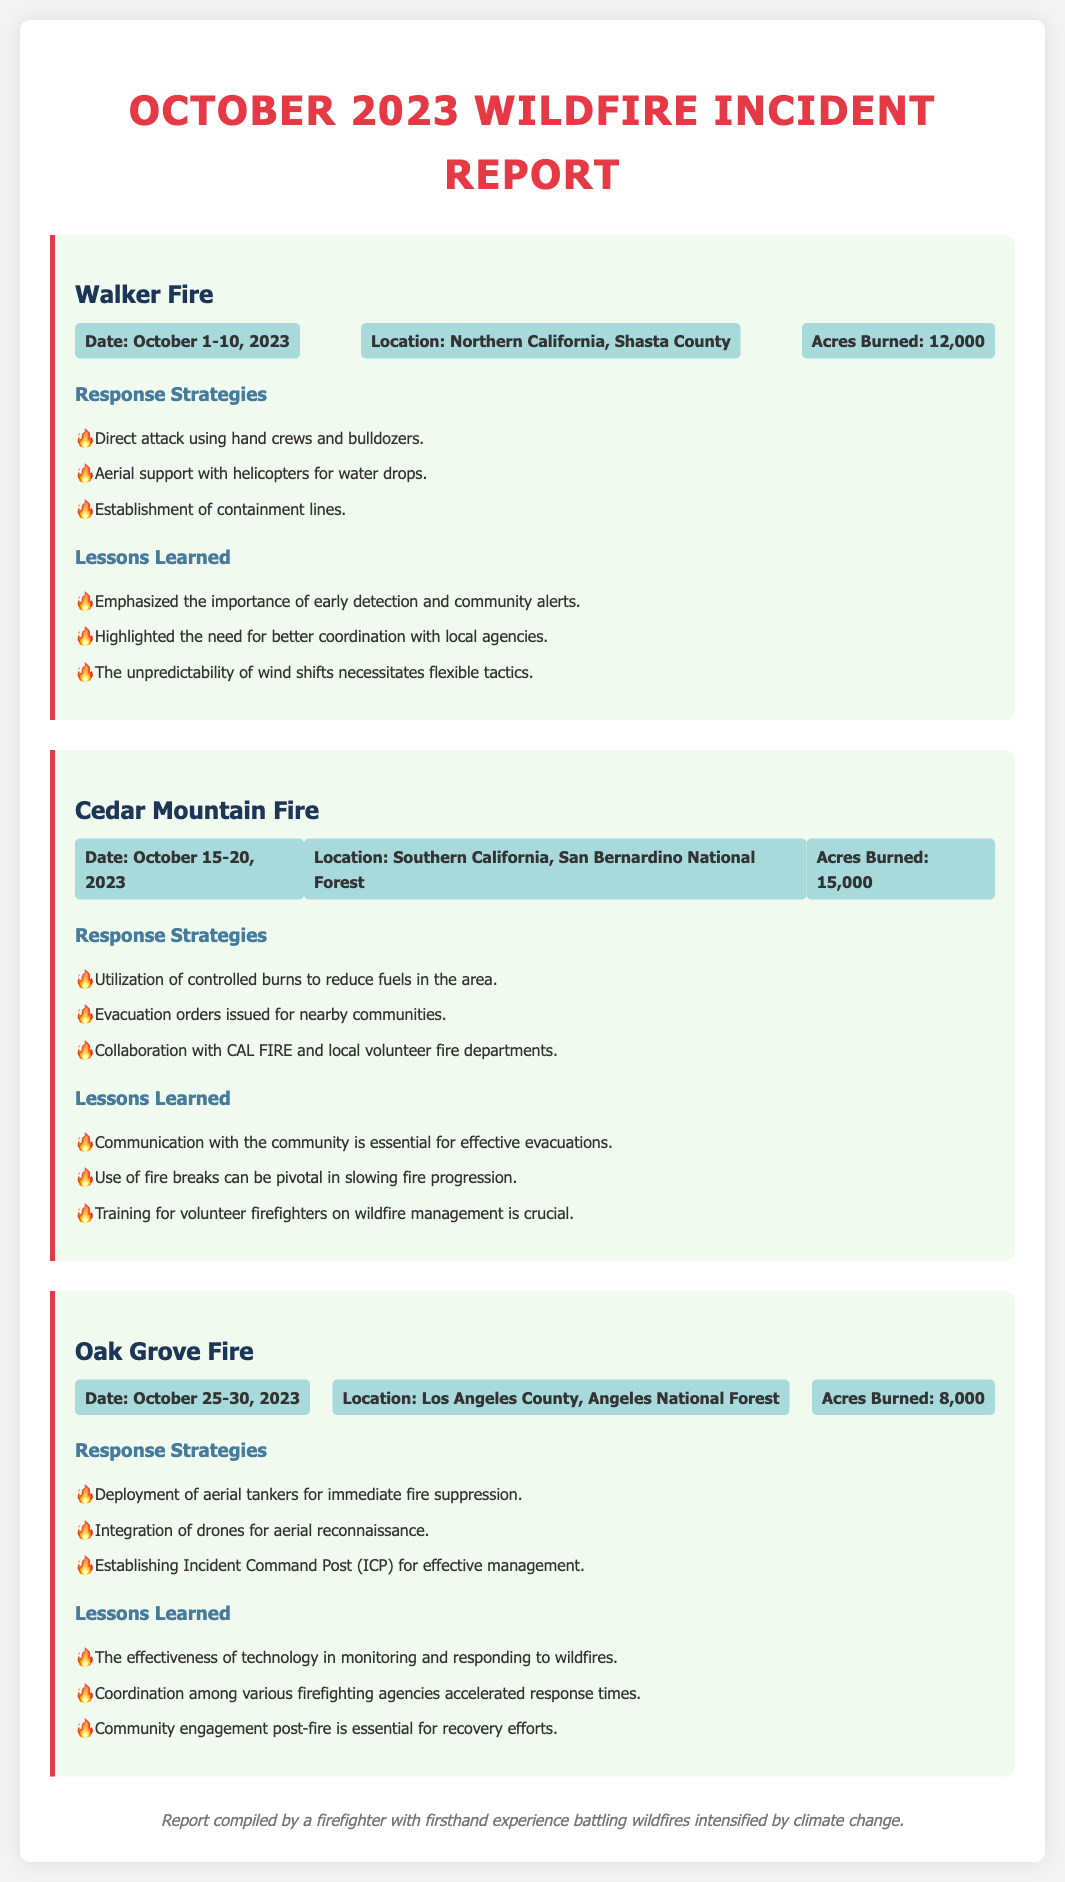What is the name of the first fire reported? The first fire reported in the document is the Walker Fire.
Answer: Walker Fire How many acres were burned in the Cedar Mountain Fire? The acres burned in the Cedar Mountain Fire is specified as 15,000 acres.
Answer: 15,000 What dates did the Oak Grove Fire occur? The Oak Grove Fire occurred from October 25 to October 30, 2023.
Answer: October 25-30, 2023 What was one strategy used in the response to the Walker Fire? One strategy used in the response to the Walker Fire was direct attack using hand crews and bulldozers.
Answer: Direct attack using hand crews and bulldozers Which location experienced the earliest wildfire in October? The earliest wildfire in October took place in Northern California, Shasta County.
Answer: Northern California, Shasta County What lesson was learned regarding community communication during the Cedar Mountain Fire? A lesson learned was that communication with the community is essential for effective evacuations.
Answer: Communication with the community is essential for effective evacuations What role did drones play in the Oak Grove Fire response? Drones were integrated for aerial reconnaissance during the Oak Grove Fire response.
Answer: Aerial reconnaissance What common theme appears in the lessons learned across all incidents? A common theme is the importance of community engagement and communication before, during, and after the incidents.
Answer: Importance of community engagement and communication 